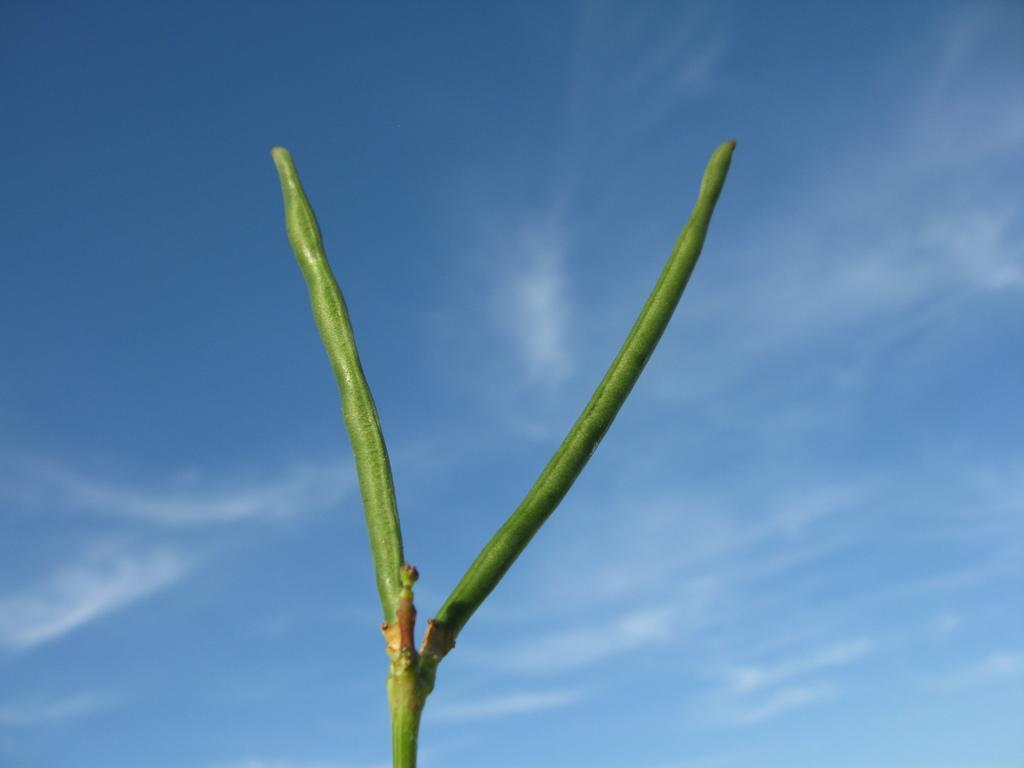Could you give a brief overview of what you see in this image? Here we can see stem of a plant and there is a blue background. 